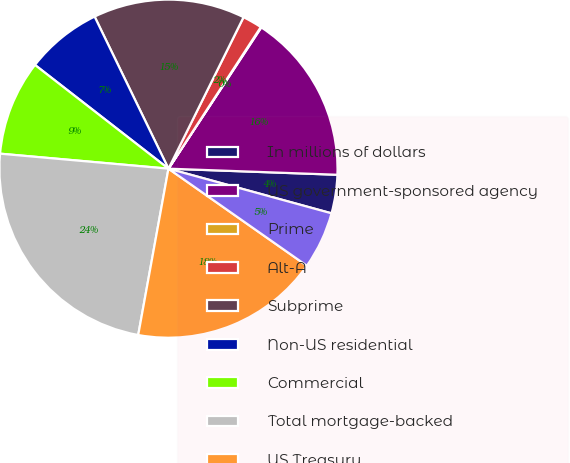<chart> <loc_0><loc_0><loc_500><loc_500><pie_chart><fcel>In millions of dollars<fcel>US government-sponsored agency<fcel>Prime<fcel>Alt-A<fcel>Subprime<fcel>Non-US residential<fcel>Commercial<fcel>Total mortgage-backed<fcel>US Treasury<fcel>Agency obligations<nl><fcel>3.68%<fcel>16.32%<fcel>0.06%<fcel>1.87%<fcel>14.52%<fcel>7.29%<fcel>9.1%<fcel>23.55%<fcel>18.13%<fcel>5.48%<nl></chart> 